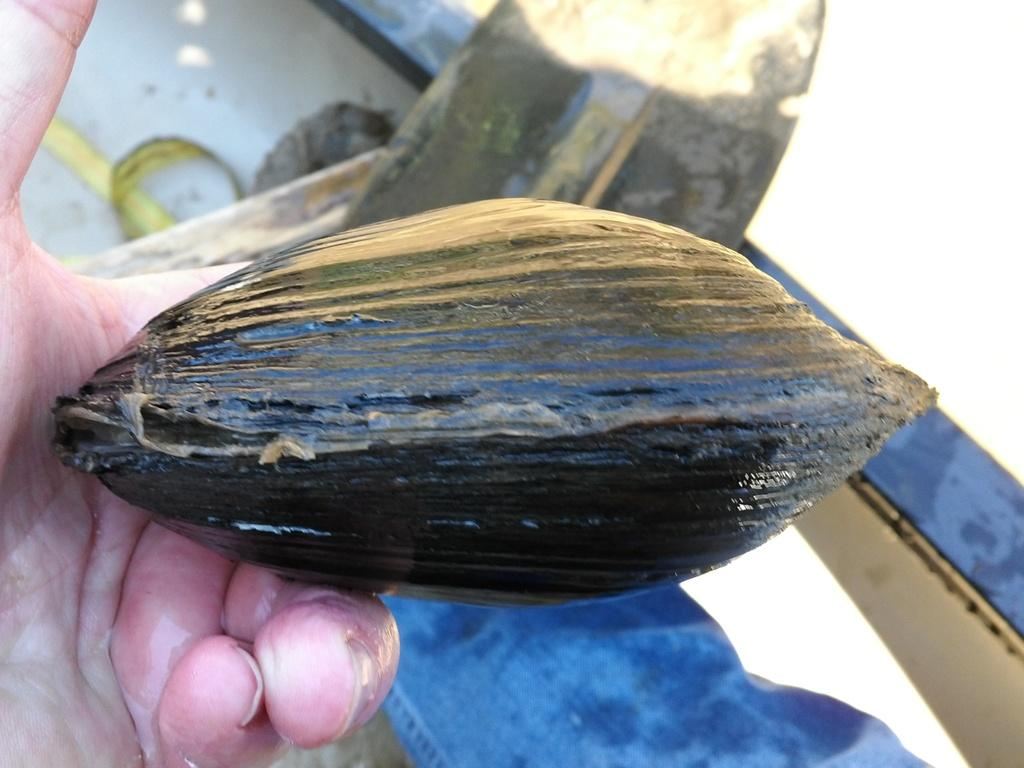What is located in the foreground of the image? There is a shell in the foreground of the image. Who or what is holding the shell? A hand is holding the shell. Can you describe the background of the image? The background of the image is not clear. What is the price of the goat in the image? There is no goat present in the image, so it is not possible to determine its price. 